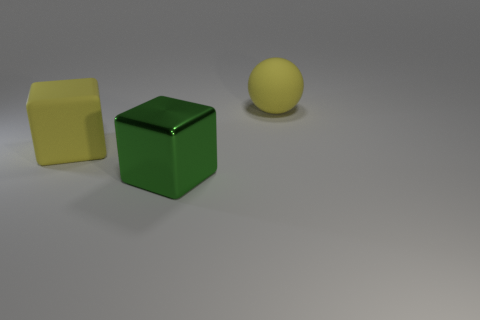Could the lighting in the image provide any clues about the setting? The lighting in the image is diffuse and seems to come from no specific direction, which minimizes harsh shadows and gives an even light to the objects. This type of lighting is often used in professional photography or scientific settings to provide a clear view of the subject without the distraction of shadow play. It suggests a controlled environment, possibly a studio or indoor space designed for photography or product display. 